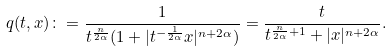Convert formula to latex. <formula><loc_0><loc_0><loc_500><loc_500>q ( t , x ) \colon = \frac { 1 } { t ^ { \frac { n } { 2 \alpha } } ( 1 + | t ^ { - \frac { 1 } { 2 \alpha } } x | ^ { n + 2 \alpha } ) } = \frac { t } { t ^ { \frac { n } { 2 \alpha } + 1 } + | x | ^ { n + 2 \alpha } } .</formula> 